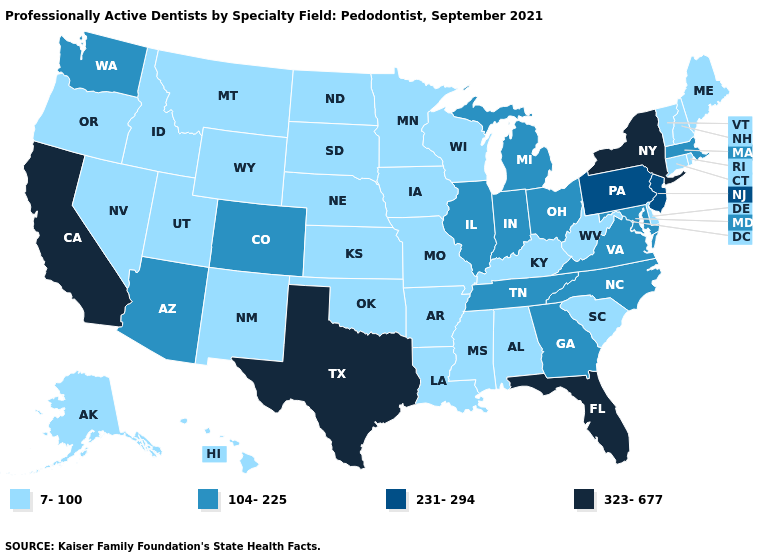What is the value of Pennsylvania?
Give a very brief answer. 231-294. What is the lowest value in states that border Maine?
Write a very short answer. 7-100. What is the highest value in states that border Colorado?
Answer briefly. 104-225. Name the states that have a value in the range 323-677?
Give a very brief answer. California, Florida, New York, Texas. What is the lowest value in the USA?
Give a very brief answer. 7-100. What is the value of Michigan?
Answer briefly. 104-225. What is the highest value in the USA?
Quick response, please. 323-677. What is the value of Maryland?
Be succinct. 104-225. Which states have the lowest value in the USA?
Answer briefly. Alabama, Alaska, Arkansas, Connecticut, Delaware, Hawaii, Idaho, Iowa, Kansas, Kentucky, Louisiana, Maine, Minnesota, Mississippi, Missouri, Montana, Nebraska, Nevada, New Hampshire, New Mexico, North Dakota, Oklahoma, Oregon, Rhode Island, South Carolina, South Dakota, Utah, Vermont, West Virginia, Wisconsin, Wyoming. Which states have the highest value in the USA?
Short answer required. California, Florida, New York, Texas. What is the lowest value in the USA?
Short answer required. 7-100. Name the states that have a value in the range 231-294?
Give a very brief answer. New Jersey, Pennsylvania. Does the map have missing data?
Keep it brief. No. What is the value of Massachusetts?
Short answer required. 104-225. How many symbols are there in the legend?
Keep it brief. 4. 